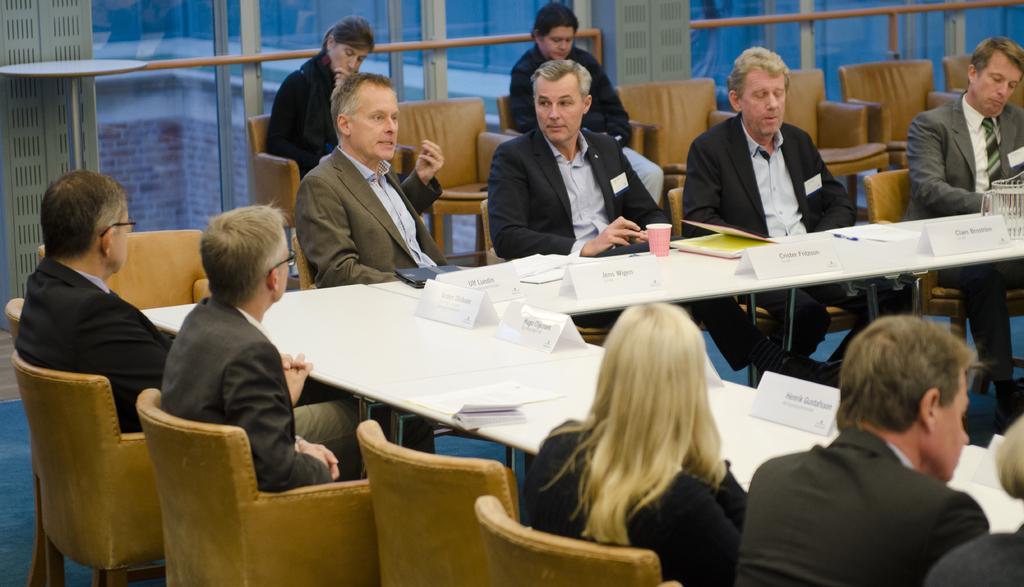Can you describe this image briefly? In this picture I can observe some people sitting on the chairs around the table. There are name boards and a glass on the table. I can observe men and women in this picture. 